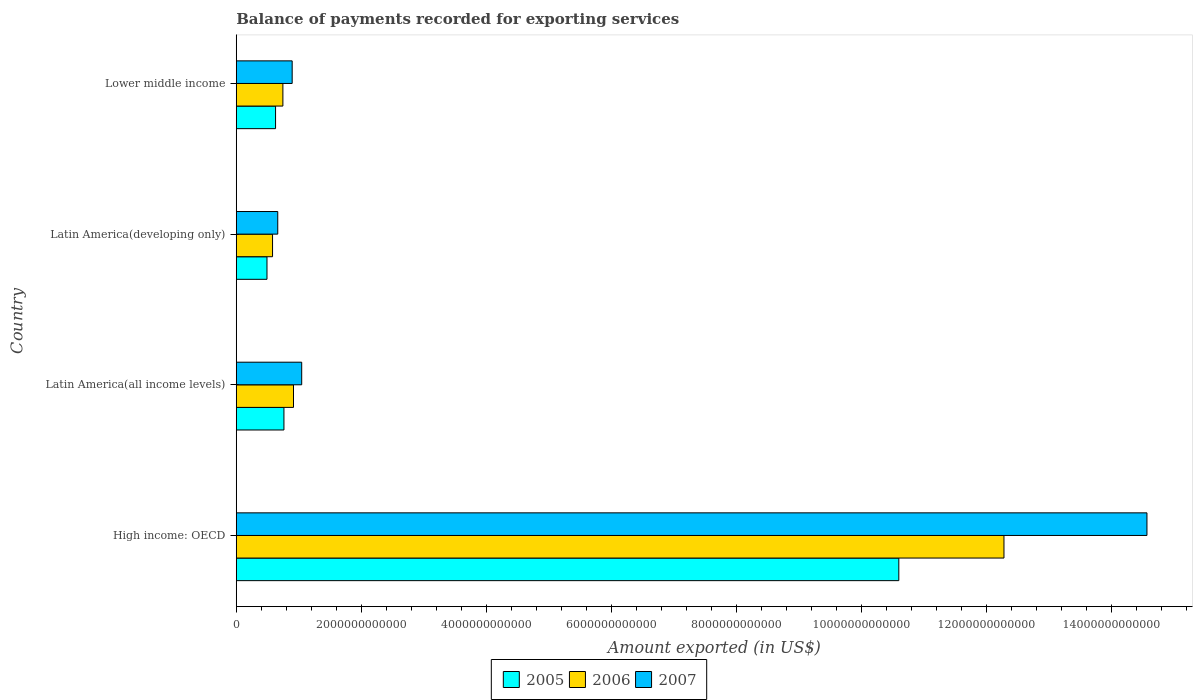How many different coloured bars are there?
Provide a short and direct response. 3. How many groups of bars are there?
Give a very brief answer. 4. Are the number of bars per tick equal to the number of legend labels?
Offer a terse response. Yes. Are the number of bars on each tick of the Y-axis equal?
Your response must be concise. Yes. How many bars are there on the 2nd tick from the bottom?
Offer a terse response. 3. What is the label of the 4th group of bars from the top?
Your answer should be very brief. High income: OECD. What is the amount exported in 2007 in Lower middle income?
Your answer should be compact. 8.95e+11. Across all countries, what is the maximum amount exported in 2005?
Make the answer very short. 1.06e+13. Across all countries, what is the minimum amount exported in 2005?
Ensure brevity in your answer.  4.92e+11. In which country was the amount exported in 2007 maximum?
Your answer should be compact. High income: OECD. In which country was the amount exported in 2005 minimum?
Your response must be concise. Latin America(developing only). What is the total amount exported in 2007 in the graph?
Ensure brevity in your answer.  1.72e+13. What is the difference between the amount exported in 2007 in High income: OECD and that in Lower middle income?
Your response must be concise. 1.37e+13. What is the difference between the amount exported in 2005 in High income: OECD and the amount exported in 2006 in Latin America(developing only)?
Your response must be concise. 1.00e+13. What is the average amount exported in 2005 per country?
Provide a succinct answer. 3.12e+12. What is the difference between the amount exported in 2006 and amount exported in 2005 in High income: OECD?
Give a very brief answer. 1.68e+12. In how many countries, is the amount exported in 2007 greater than 6800000000000 US$?
Provide a short and direct response. 1. What is the ratio of the amount exported in 2006 in Latin America(developing only) to that in Lower middle income?
Offer a very short reply. 0.78. What is the difference between the highest and the second highest amount exported in 2007?
Give a very brief answer. 1.35e+13. What is the difference between the highest and the lowest amount exported in 2007?
Give a very brief answer. 1.39e+13. What does the 2nd bar from the top in Latin America(all income levels) represents?
Your answer should be very brief. 2006. Is it the case that in every country, the sum of the amount exported in 2005 and amount exported in 2007 is greater than the amount exported in 2006?
Provide a succinct answer. Yes. Are all the bars in the graph horizontal?
Offer a terse response. Yes. How many countries are there in the graph?
Give a very brief answer. 4. What is the difference between two consecutive major ticks on the X-axis?
Your answer should be very brief. 2.00e+12. Does the graph contain any zero values?
Ensure brevity in your answer.  No. Does the graph contain grids?
Your answer should be very brief. No. How many legend labels are there?
Keep it short and to the point. 3. What is the title of the graph?
Your response must be concise. Balance of payments recorded for exporting services. Does "1986" appear as one of the legend labels in the graph?
Offer a very short reply. No. What is the label or title of the X-axis?
Give a very brief answer. Amount exported (in US$). What is the Amount exported (in US$) in 2005 in High income: OECD?
Give a very brief answer. 1.06e+13. What is the Amount exported (in US$) in 2006 in High income: OECD?
Make the answer very short. 1.23e+13. What is the Amount exported (in US$) of 2007 in High income: OECD?
Keep it short and to the point. 1.46e+13. What is the Amount exported (in US$) of 2005 in Latin America(all income levels)?
Your response must be concise. 7.63e+11. What is the Amount exported (in US$) in 2006 in Latin America(all income levels)?
Provide a short and direct response. 9.16e+11. What is the Amount exported (in US$) of 2007 in Latin America(all income levels)?
Provide a succinct answer. 1.05e+12. What is the Amount exported (in US$) of 2005 in Latin America(developing only)?
Offer a terse response. 4.92e+11. What is the Amount exported (in US$) in 2006 in Latin America(developing only)?
Offer a terse response. 5.81e+11. What is the Amount exported (in US$) of 2007 in Latin America(developing only)?
Your answer should be compact. 6.64e+11. What is the Amount exported (in US$) in 2005 in Lower middle income?
Your answer should be very brief. 6.29e+11. What is the Amount exported (in US$) of 2006 in Lower middle income?
Ensure brevity in your answer.  7.46e+11. What is the Amount exported (in US$) in 2007 in Lower middle income?
Make the answer very short. 8.95e+11. Across all countries, what is the maximum Amount exported (in US$) in 2005?
Give a very brief answer. 1.06e+13. Across all countries, what is the maximum Amount exported (in US$) in 2006?
Offer a very short reply. 1.23e+13. Across all countries, what is the maximum Amount exported (in US$) in 2007?
Offer a very short reply. 1.46e+13. Across all countries, what is the minimum Amount exported (in US$) in 2005?
Provide a succinct answer. 4.92e+11. Across all countries, what is the minimum Amount exported (in US$) in 2006?
Your answer should be compact. 5.81e+11. Across all countries, what is the minimum Amount exported (in US$) in 2007?
Your answer should be very brief. 6.64e+11. What is the total Amount exported (in US$) in 2005 in the graph?
Your answer should be very brief. 1.25e+13. What is the total Amount exported (in US$) in 2006 in the graph?
Keep it short and to the point. 1.45e+13. What is the total Amount exported (in US$) in 2007 in the graph?
Keep it short and to the point. 1.72e+13. What is the difference between the Amount exported (in US$) of 2005 in High income: OECD and that in Latin America(all income levels)?
Offer a terse response. 9.84e+12. What is the difference between the Amount exported (in US$) in 2006 in High income: OECD and that in Latin America(all income levels)?
Your answer should be very brief. 1.14e+13. What is the difference between the Amount exported (in US$) in 2007 in High income: OECD and that in Latin America(all income levels)?
Keep it short and to the point. 1.35e+13. What is the difference between the Amount exported (in US$) of 2005 in High income: OECD and that in Latin America(developing only)?
Offer a very short reply. 1.01e+13. What is the difference between the Amount exported (in US$) in 2006 in High income: OECD and that in Latin America(developing only)?
Ensure brevity in your answer.  1.17e+13. What is the difference between the Amount exported (in US$) in 2007 in High income: OECD and that in Latin America(developing only)?
Provide a succinct answer. 1.39e+13. What is the difference between the Amount exported (in US$) of 2005 in High income: OECD and that in Lower middle income?
Provide a short and direct response. 9.97e+12. What is the difference between the Amount exported (in US$) in 2006 in High income: OECD and that in Lower middle income?
Provide a succinct answer. 1.15e+13. What is the difference between the Amount exported (in US$) of 2007 in High income: OECD and that in Lower middle income?
Ensure brevity in your answer.  1.37e+13. What is the difference between the Amount exported (in US$) in 2005 in Latin America(all income levels) and that in Latin America(developing only)?
Make the answer very short. 2.71e+11. What is the difference between the Amount exported (in US$) in 2006 in Latin America(all income levels) and that in Latin America(developing only)?
Provide a short and direct response. 3.35e+11. What is the difference between the Amount exported (in US$) in 2007 in Latin America(all income levels) and that in Latin America(developing only)?
Offer a very short reply. 3.83e+11. What is the difference between the Amount exported (in US$) in 2005 in Latin America(all income levels) and that in Lower middle income?
Offer a very short reply. 1.34e+11. What is the difference between the Amount exported (in US$) of 2006 in Latin America(all income levels) and that in Lower middle income?
Your response must be concise. 1.70e+11. What is the difference between the Amount exported (in US$) in 2007 in Latin America(all income levels) and that in Lower middle income?
Provide a short and direct response. 1.52e+11. What is the difference between the Amount exported (in US$) of 2005 in Latin America(developing only) and that in Lower middle income?
Your answer should be compact. -1.37e+11. What is the difference between the Amount exported (in US$) of 2006 in Latin America(developing only) and that in Lower middle income?
Provide a succinct answer. -1.65e+11. What is the difference between the Amount exported (in US$) of 2007 in Latin America(developing only) and that in Lower middle income?
Your answer should be very brief. -2.31e+11. What is the difference between the Amount exported (in US$) in 2005 in High income: OECD and the Amount exported (in US$) in 2006 in Latin America(all income levels)?
Provide a succinct answer. 9.69e+12. What is the difference between the Amount exported (in US$) in 2005 in High income: OECD and the Amount exported (in US$) in 2007 in Latin America(all income levels)?
Provide a short and direct response. 9.56e+12. What is the difference between the Amount exported (in US$) of 2006 in High income: OECD and the Amount exported (in US$) of 2007 in Latin America(all income levels)?
Provide a short and direct response. 1.12e+13. What is the difference between the Amount exported (in US$) in 2005 in High income: OECD and the Amount exported (in US$) in 2006 in Latin America(developing only)?
Keep it short and to the point. 1.00e+13. What is the difference between the Amount exported (in US$) in 2005 in High income: OECD and the Amount exported (in US$) in 2007 in Latin America(developing only)?
Keep it short and to the point. 9.94e+12. What is the difference between the Amount exported (in US$) in 2006 in High income: OECD and the Amount exported (in US$) in 2007 in Latin America(developing only)?
Provide a succinct answer. 1.16e+13. What is the difference between the Amount exported (in US$) in 2005 in High income: OECD and the Amount exported (in US$) in 2006 in Lower middle income?
Provide a succinct answer. 9.86e+12. What is the difference between the Amount exported (in US$) in 2005 in High income: OECD and the Amount exported (in US$) in 2007 in Lower middle income?
Keep it short and to the point. 9.71e+12. What is the difference between the Amount exported (in US$) in 2006 in High income: OECD and the Amount exported (in US$) in 2007 in Lower middle income?
Your response must be concise. 1.14e+13. What is the difference between the Amount exported (in US$) of 2005 in Latin America(all income levels) and the Amount exported (in US$) of 2006 in Latin America(developing only)?
Provide a succinct answer. 1.82e+11. What is the difference between the Amount exported (in US$) in 2005 in Latin America(all income levels) and the Amount exported (in US$) in 2007 in Latin America(developing only)?
Your answer should be compact. 9.91e+1. What is the difference between the Amount exported (in US$) in 2006 in Latin America(all income levels) and the Amount exported (in US$) in 2007 in Latin America(developing only)?
Offer a terse response. 2.52e+11. What is the difference between the Amount exported (in US$) in 2005 in Latin America(all income levels) and the Amount exported (in US$) in 2006 in Lower middle income?
Your answer should be very brief. 1.69e+1. What is the difference between the Amount exported (in US$) of 2005 in Latin America(all income levels) and the Amount exported (in US$) of 2007 in Lower middle income?
Offer a terse response. -1.32e+11. What is the difference between the Amount exported (in US$) in 2006 in Latin America(all income levels) and the Amount exported (in US$) in 2007 in Lower middle income?
Your answer should be very brief. 2.11e+1. What is the difference between the Amount exported (in US$) of 2005 in Latin America(developing only) and the Amount exported (in US$) of 2006 in Lower middle income?
Give a very brief answer. -2.54e+11. What is the difference between the Amount exported (in US$) in 2005 in Latin America(developing only) and the Amount exported (in US$) in 2007 in Lower middle income?
Give a very brief answer. -4.03e+11. What is the difference between the Amount exported (in US$) in 2006 in Latin America(developing only) and the Amount exported (in US$) in 2007 in Lower middle income?
Provide a short and direct response. -3.14e+11. What is the average Amount exported (in US$) in 2005 per country?
Your answer should be very brief. 3.12e+12. What is the average Amount exported (in US$) in 2006 per country?
Keep it short and to the point. 3.63e+12. What is the average Amount exported (in US$) in 2007 per country?
Your answer should be very brief. 4.30e+12. What is the difference between the Amount exported (in US$) in 2005 and Amount exported (in US$) in 2006 in High income: OECD?
Offer a very short reply. -1.68e+12. What is the difference between the Amount exported (in US$) in 2005 and Amount exported (in US$) in 2007 in High income: OECD?
Your response must be concise. -3.97e+12. What is the difference between the Amount exported (in US$) in 2006 and Amount exported (in US$) in 2007 in High income: OECD?
Provide a succinct answer. -2.29e+12. What is the difference between the Amount exported (in US$) in 2005 and Amount exported (in US$) in 2006 in Latin America(all income levels)?
Your response must be concise. -1.53e+11. What is the difference between the Amount exported (in US$) of 2005 and Amount exported (in US$) of 2007 in Latin America(all income levels)?
Keep it short and to the point. -2.84e+11. What is the difference between the Amount exported (in US$) of 2006 and Amount exported (in US$) of 2007 in Latin America(all income levels)?
Your answer should be very brief. -1.31e+11. What is the difference between the Amount exported (in US$) in 2005 and Amount exported (in US$) in 2006 in Latin America(developing only)?
Provide a short and direct response. -8.89e+1. What is the difference between the Amount exported (in US$) in 2005 and Amount exported (in US$) in 2007 in Latin America(developing only)?
Provide a succinct answer. -1.72e+11. What is the difference between the Amount exported (in US$) of 2006 and Amount exported (in US$) of 2007 in Latin America(developing only)?
Provide a succinct answer. -8.33e+1. What is the difference between the Amount exported (in US$) of 2005 and Amount exported (in US$) of 2006 in Lower middle income?
Your answer should be compact. -1.17e+11. What is the difference between the Amount exported (in US$) of 2005 and Amount exported (in US$) of 2007 in Lower middle income?
Your answer should be very brief. -2.66e+11. What is the difference between the Amount exported (in US$) in 2006 and Amount exported (in US$) in 2007 in Lower middle income?
Provide a succinct answer. -1.49e+11. What is the ratio of the Amount exported (in US$) in 2005 in High income: OECD to that in Latin America(all income levels)?
Your answer should be very brief. 13.89. What is the ratio of the Amount exported (in US$) in 2006 in High income: OECD to that in Latin America(all income levels)?
Your answer should be compact. 13.41. What is the ratio of the Amount exported (in US$) of 2007 in High income: OECD to that in Latin America(all income levels)?
Offer a very short reply. 13.91. What is the ratio of the Amount exported (in US$) in 2005 in High income: OECD to that in Latin America(developing only)?
Offer a very short reply. 21.56. What is the ratio of the Amount exported (in US$) of 2006 in High income: OECD to that in Latin America(developing only)?
Provide a succinct answer. 21.16. What is the ratio of the Amount exported (in US$) in 2007 in High income: OECD to that in Latin America(developing only)?
Provide a succinct answer. 21.95. What is the ratio of the Amount exported (in US$) in 2005 in High income: OECD to that in Lower middle income?
Keep it short and to the point. 16.86. What is the ratio of the Amount exported (in US$) of 2006 in High income: OECD to that in Lower middle income?
Provide a short and direct response. 16.46. What is the ratio of the Amount exported (in US$) of 2007 in High income: OECD to that in Lower middle income?
Offer a terse response. 16.28. What is the ratio of the Amount exported (in US$) of 2005 in Latin America(all income levels) to that in Latin America(developing only)?
Provide a short and direct response. 1.55. What is the ratio of the Amount exported (in US$) of 2006 in Latin America(all income levels) to that in Latin America(developing only)?
Provide a succinct answer. 1.58. What is the ratio of the Amount exported (in US$) of 2007 in Latin America(all income levels) to that in Latin America(developing only)?
Ensure brevity in your answer.  1.58. What is the ratio of the Amount exported (in US$) in 2005 in Latin America(all income levels) to that in Lower middle income?
Keep it short and to the point. 1.21. What is the ratio of the Amount exported (in US$) of 2006 in Latin America(all income levels) to that in Lower middle income?
Provide a short and direct response. 1.23. What is the ratio of the Amount exported (in US$) of 2007 in Latin America(all income levels) to that in Lower middle income?
Your response must be concise. 1.17. What is the ratio of the Amount exported (in US$) in 2005 in Latin America(developing only) to that in Lower middle income?
Provide a short and direct response. 0.78. What is the ratio of the Amount exported (in US$) of 2006 in Latin America(developing only) to that in Lower middle income?
Your response must be concise. 0.78. What is the ratio of the Amount exported (in US$) of 2007 in Latin America(developing only) to that in Lower middle income?
Offer a terse response. 0.74. What is the difference between the highest and the second highest Amount exported (in US$) of 2005?
Your answer should be compact. 9.84e+12. What is the difference between the highest and the second highest Amount exported (in US$) of 2006?
Your answer should be compact. 1.14e+13. What is the difference between the highest and the second highest Amount exported (in US$) of 2007?
Offer a very short reply. 1.35e+13. What is the difference between the highest and the lowest Amount exported (in US$) of 2005?
Your response must be concise. 1.01e+13. What is the difference between the highest and the lowest Amount exported (in US$) in 2006?
Provide a succinct answer. 1.17e+13. What is the difference between the highest and the lowest Amount exported (in US$) in 2007?
Provide a succinct answer. 1.39e+13. 